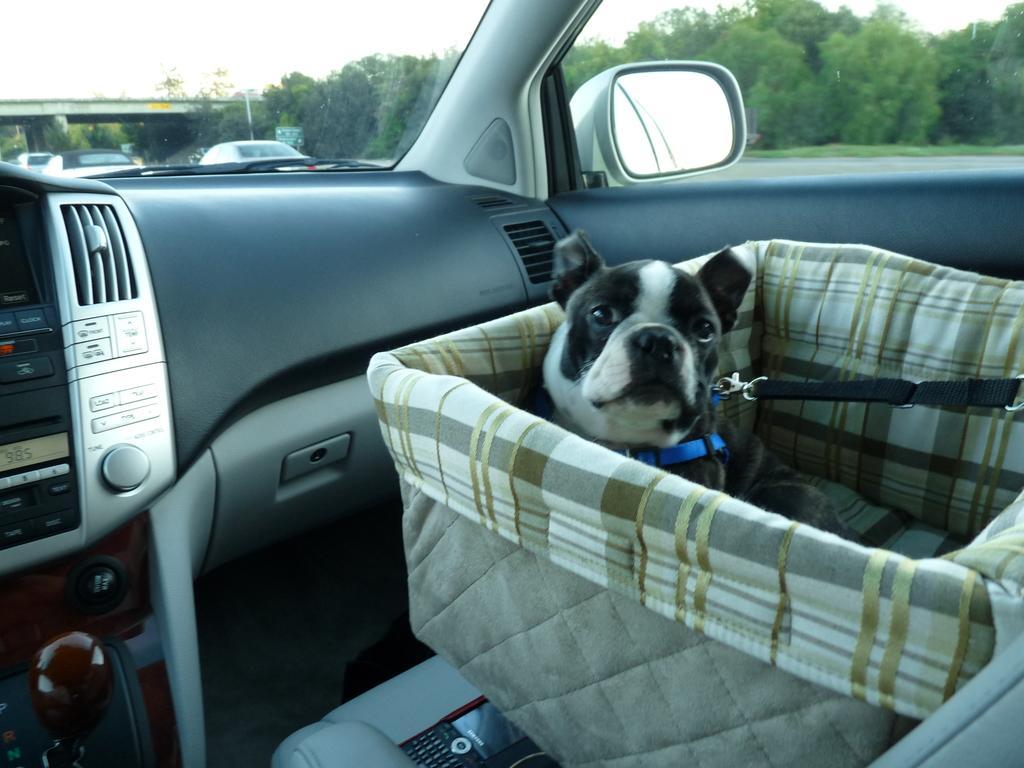In one or two sentences, can you explain what this image depicts? In this image i can see a dog in the basket which is in the car. In the background i can see a bridge, few vehicles, few trees and the sky. 